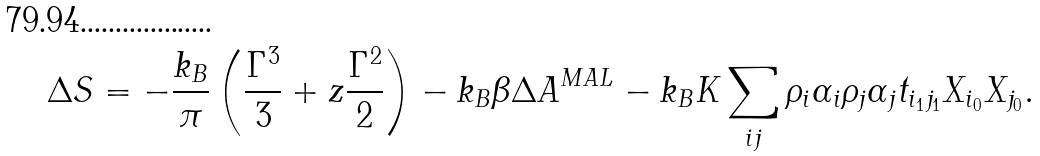Convert formula to latex. <formula><loc_0><loc_0><loc_500><loc_500>\Delta S = - \frac { k _ { B } } { \pi } \left ( \frac { { \Gamma } ^ { 3 } } { 3 } + z \frac { { \Gamma } ^ { 2 } } { 2 } \right ) - k _ { B } \beta \Delta A ^ { M A L } - k _ { B } K \sum _ { i j } \rho _ { i } \alpha _ { i } \rho _ { j } \alpha _ { j } t _ { i _ { 1 } j _ { 1 } } X _ { i _ { 0 } } X _ { j _ { 0 } } .</formula> 